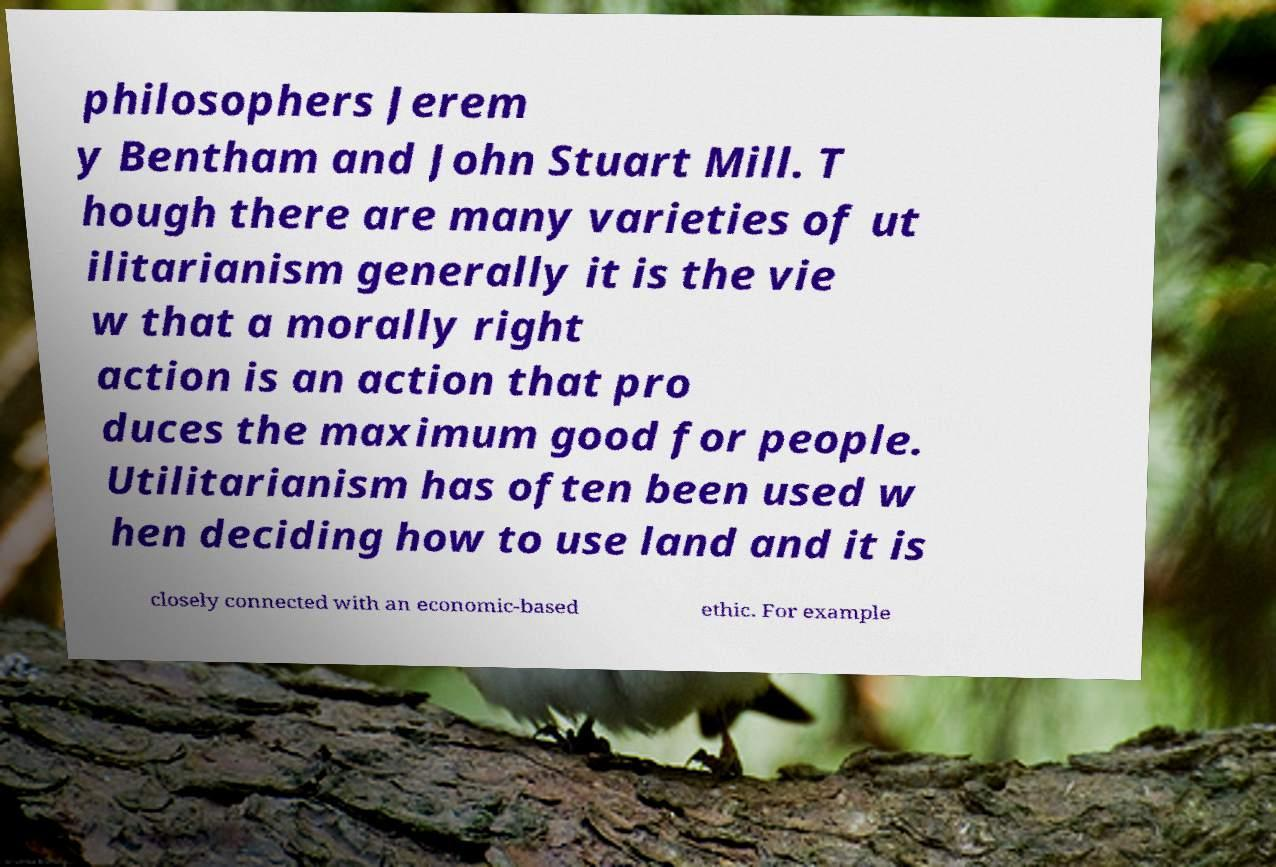What messages or text are displayed in this image? I need them in a readable, typed format. philosophers Jerem y Bentham and John Stuart Mill. T hough there are many varieties of ut ilitarianism generally it is the vie w that a morally right action is an action that pro duces the maximum good for people. Utilitarianism has often been used w hen deciding how to use land and it is closely connected with an economic-based ethic. For example 